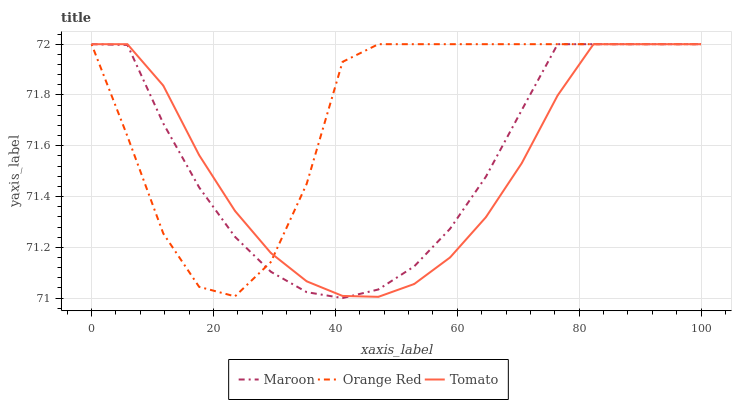Does Tomato have the minimum area under the curve?
Answer yes or no. Yes. Does Orange Red have the maximum area under the curve?
Answer yes or no. Yes. Does Maroon have the minimum area under the curve?
Answer yes or no. No. Does Maroon have the maximum area under the curve?
Answer yes or no. No. Is Tomato the smoothest?
Answer yes or no. Yes. Is Orange Red the roughest?
Answer yes or no. Yes. Is Maroon the smoothest?
Answer yes or no. No. Is Maroon the roughest?
Answer yes or no. No. Does Maroon have the lowest value?
Answer yes or no. Yes. Does Orange Red have the lowest value?
Answer yes or no. No. Does Maroon have the highest value?
Answer yes or no. Yes. Does Orange Red intersect Maroon?
Answer yes or no. Yes. Is Orange Red less than Maroon?
Answer yes or no. No. Is Orange Red greater than Maroon?
Answer yes or no. No. 